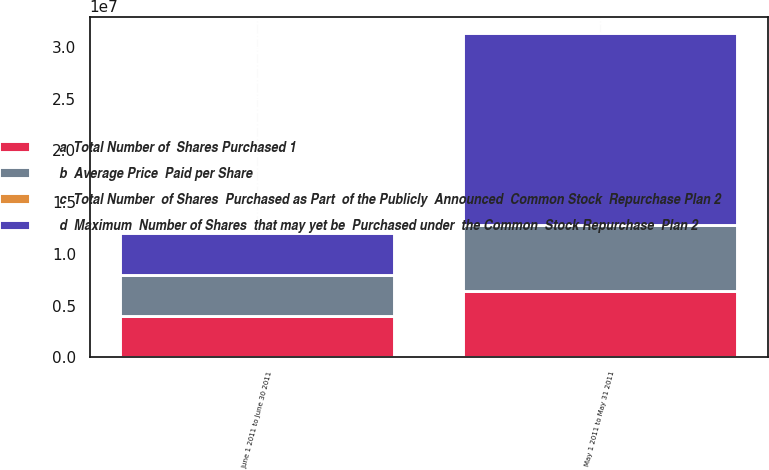<chart> <loc_0><loc_0><loc_500><loc_500><stacked_bar_chart><ecel><fcel>May 1 2011 to May 31 2011<fcel>June 1 2011 to June 30 2011<nl><fcel>b  Average Price  Paid per Share<fcel>6.40056e+06<fcel>4.00015e+06<nl><fcel>c  Total Number  of Shares  Purchased as Part  of the Publicly  Announced  Common Stock  Repurchase Plan 2<fcel>53.93<fcel>53.22<nl><fcel>a  Total Number of  Shares Purchased 1<fcel>6.4e+06<fcel>4e+06<nl><fcel>d  Maximum  Number of Shares  that may yet be  Purchased under  the Common  Stock Repurchase  Plan 2<fcel>1.85595e+07<fcel>4.00015e+06<nl></chart> 